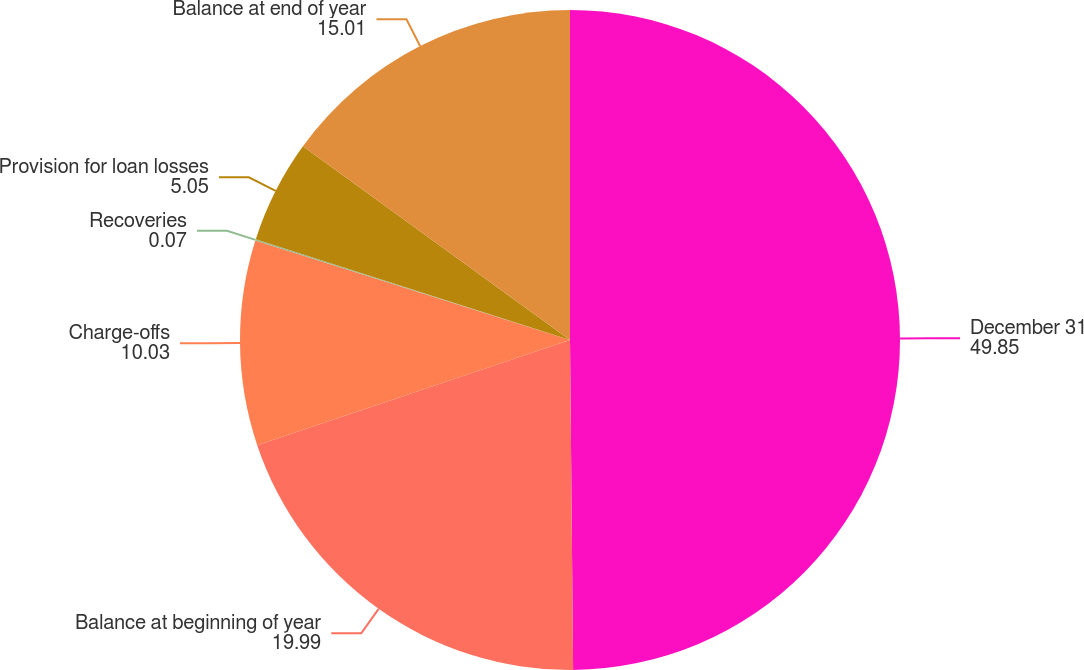<chart> <loc_0><loc_0><loc_500><loc_500><pie_chart><fcel>December 31<fcel>Balance at beginning of year<fcel>Charge-offs<fcel>Recoveries<fcel>Provision for loan losses<fcel>Balance at end of year<nl><fcel>49.85%<fcel>19.99%<fcel>10.03%<fcel>0.07%<fcel>5.05%<fcel>15.01%<nl></chart> 